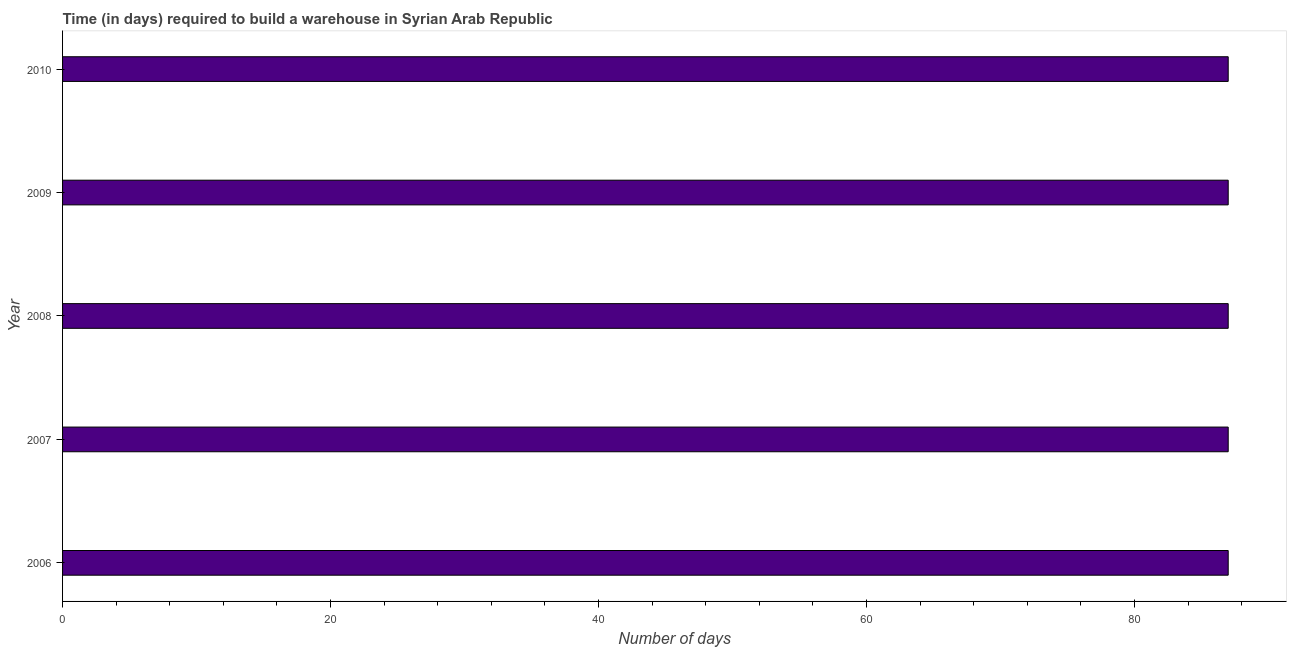What is the title of the graph?
Your response must be concise. Time (in days) required to build a warehouse in Syrian Arab Republic. What is the label or title of the X-axis?
Provide a succinct answer. Number of days. What is the time required to build a warehouse in 2006?
Give a very brief answer. 87. Across all years, what is the minimum time required to build a warehouse?
Provide a short and direct response. 87. What is the sum of the time required to build a warehouse?
Provide a short and direct response. 435. What is the difference between the time required to build a warehouse in 2008 and 2009?
Ensure brevity in your answer.  0. In how many years, is the time required to build a warehouse greater than 16 days?
Provide a short and direct response. 5. Is the time required to build a warehouse in 2007 less than that in 2010?
Your response must be concise. No. Is the difference between the time required to build a warehouse in 2006 and 2007 greater than the difference between any two years?
Ensure brevity in your answer.  Yes. Is the sum of the time required to build a warehouse in 2006 and 2010 greater than the maximum time required to build a warehouse across all years?
Keep it short and to the point. Yes. In how many years, is the time required to build a warehouse greater than the average time required to build a warehouse taken over all years?
Make the answer very short. 0. How many bars are there?
Provide a succinct answer. 5. What is the Number of days in 2007?
Ensure brevity in your answer.  87. What is the Number of days of 2008?
Provide a succinct answer. 87. What is the Number of days in 2009?
Offer a terse response. 87. What is the difference between the Number of days in 2006 and 2007?
Ensure brevity in your answer.  0. What is the difference between the Number of days in 2006 and 2009?
Your answer should be very brief. 0. What is the difference between the Number of days in 2006 and 2010?
Give a very brief answer. 0. What is the difference between the Number of days in 2007 and 2009?
Keep it short and to the point. 0. What is the difference between the Number of days in 2007 and 2010?
Offer a terse response. 0. What is the difference between the Number of days in 2008 and 2009?
Offer a terse response. 0. What is the difference between the Number of days in 2008 and 2010?
Your response must be concise. 0. What is the ratio of the Number of days in 2006 to that in 2007?
Provide a succinct answer. 1. What is the ratio of the Number of days in 2008 to that in 2010?
Offer a very short reply. 1. 